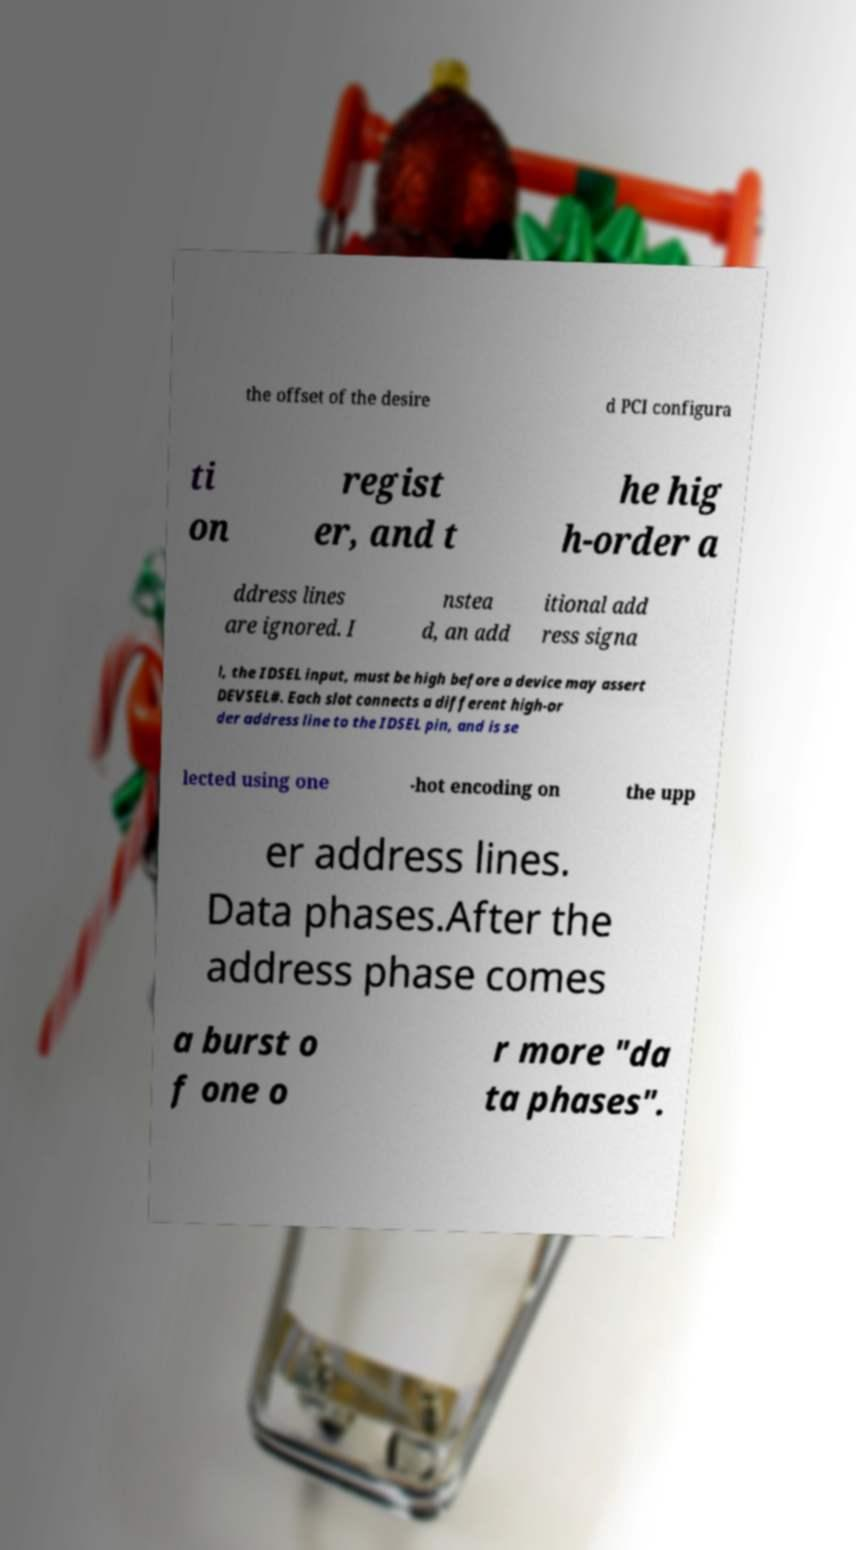Can you accurately transcribe the text from the provided image for me? the offset of the desire d PCI configura ti on regist er, and t he hig h-order a ddress lines are ignored. I nstea d, an add itional add ress signa l, the IDSEL input, must be high before a device may assert DEVSEL#. Each slot connects a different high-or der address line to the IDSEL pin, and is se lected using one -hot encoding on the upp er address lines. Data phases.After the address phase comes a burst o f one o r more "da ta phases". 